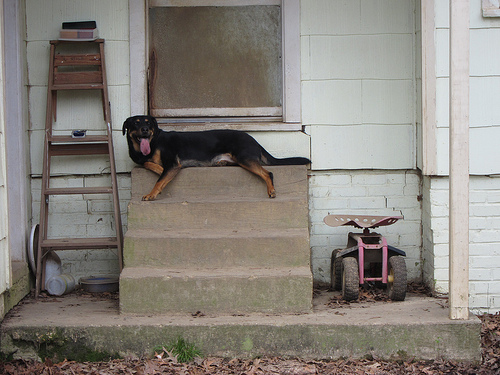<image>
Can you confirm if the dog is on the stairs? Yes. Looking at the image, I can see the dog is positioned on top of the stairs, with the stairs providing support. Where is the dog in relation to the toy? Is it to the left of the toy? Yes. From this viewpoint, the dog is positioned to the left side relative to the toy. Where is the dog in relation to the step? Is it to the left of the step? No. The dog is not to the left of the step. From this viewpoint, they have a different horizontal relationship. 